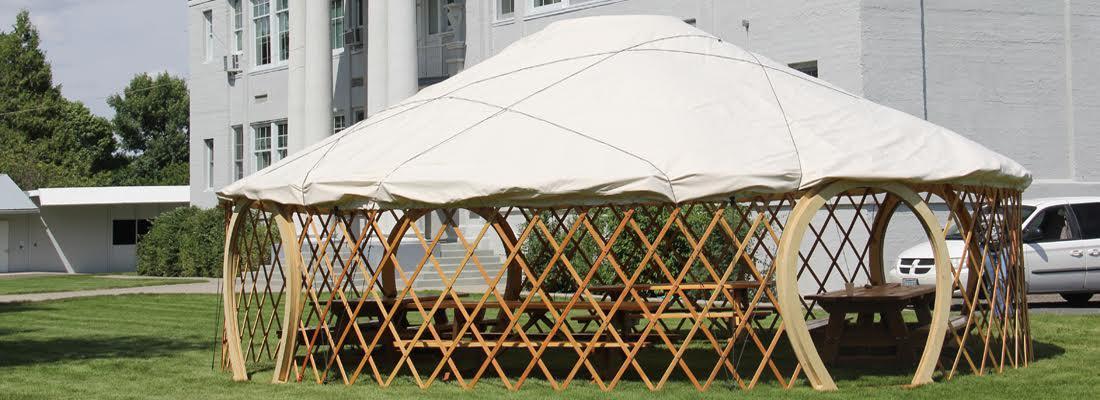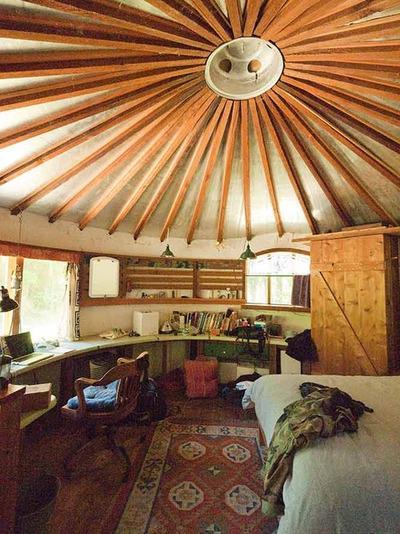The first image is the image on the left, the second image is the image on the right. Examine the images to the left and right. Is the description "One of the images is showing the hut from the outside." accurate? Answer yes or no. Yes. The first image is the image on the left, the second image is the image on the right. Analyze the images presented: Is the assertion "An image shows the exterior framework of an unfinished building with a cone-shaped roof." valid? Answer yes or no. Yes. 